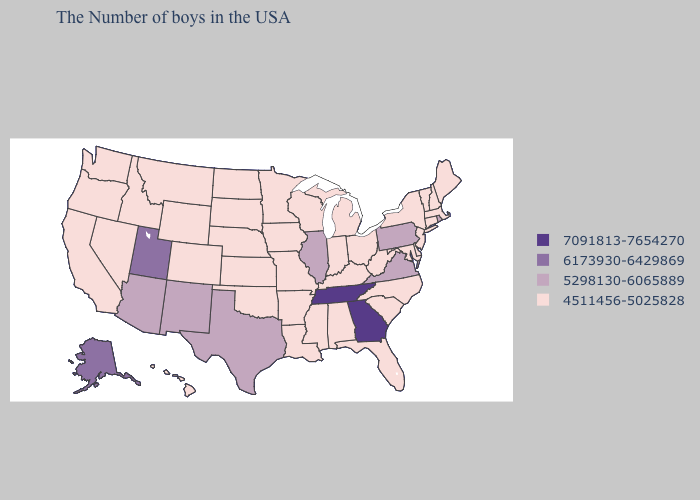Name the states that have a value in the range 7091813-7654270?
Keep it brief. Georgia, Tennessee. Does Pennsylvania have the lowest value in the Northeast?
Write a very short answer. No. Name the states that have a value in the range 7091813-7654270?
Be succinct. Georgia, Tennessee. What is the value of Massachusetts?
Give a very brief answer. 4511456-5025828. Which states have the lowest value in the South?
Be succinct. Delaware, Maryland, North Carolina, South Carolina, West Virginia, Florida, Kentucky, Alabama, Mississippi, Louisiana, Arkansas, Oklahoma. Name the states that have a value in the range 5298130-6065889?
Concise answer only. Rhode Island, Pennsylvania, Virginia, Illinois, Texas, New Mexico, Arizona. Does Rhode Island have the highest value in the Northeast?
Give a very brief answer. Yes. Name the states that have a value in the range 7091813-7654270?
Keep it brief. Georgia, Tennessee. Does Kansas have the lowest value in the USA?
Keep it brief. Yes. What is the highest value in states that border Tennessee?
Concise answer only. 7091813-7654270. Does Hawaii have the same value as North Dakota?
Write a very short answer. Yes. Does the map have missing data?
Keep it brief. No. What is the lowest value in states that border West Virginia?
Concise answer only. 4511456-5025828. What is the value of South Dakota?
Short answer required. 4511456-5025828. What is the highest value in states that border South Carolina?
Concise answer only. 7091813-7654270. 